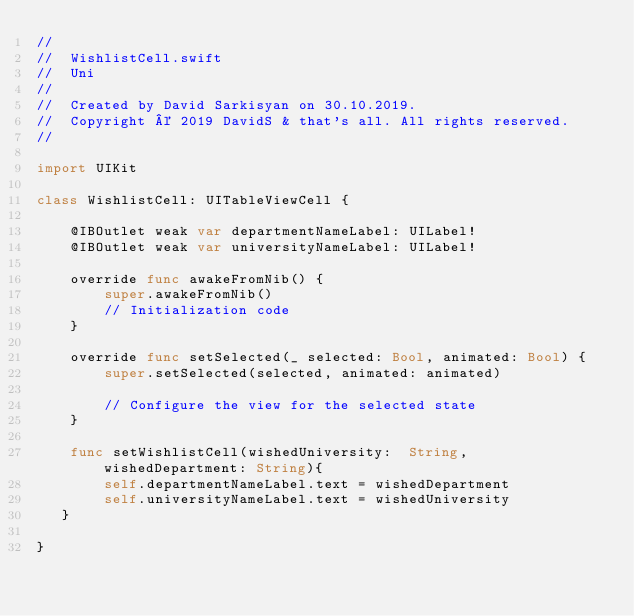<code> <loc_0><loc_0><loc_500><loc_500><_Swift_>//
//  WishlistCell.swift
//  Uni
//
//  Created by David Sarkisyan on 30.10.2019.
//  Copyright © 2019 DavidS & that's all. All rights reserved.
//

import UIKit

class WishlistCell: UITableViewCell {

    @IBOutlet weak var departmentNameLabel: UILabel!
    @IBOutlet weak var universityNameLabel: UILabel!
    
    override func awakeFromNib() {
        super.awakeFromNib()
        // Initialization code
    }

    override func setSelected(_ selected: Bool, animated: Bool) {
        super.setSelected(selected, animated: animated)

        // Configure the view for the selected state
    }

    func setWishlistCell(wishedUniversity:  String, wishedDepartment: String){
        self.departmentNameLabel.text = wishedDepartment
        self.universityNameLabel.text = wishedUniversity
   }
    
}
</code> 